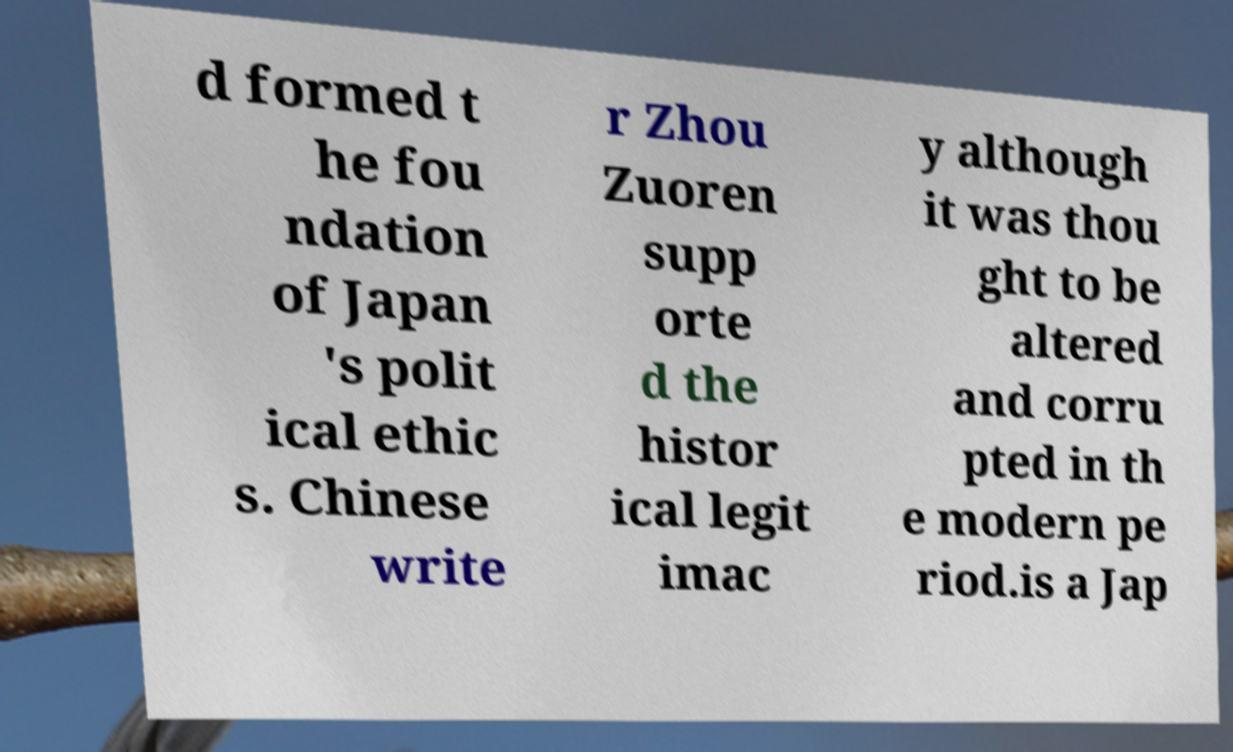Could you extract and type out the text from this image? d formed t he fou ndation of Japan 's polit ical ethic s. Chinese write r Zhou Zuoren supp orte d the histor ical legit imac y although it was thou ght to be altered and corru pted in th e modern pe riod.is a Jap 